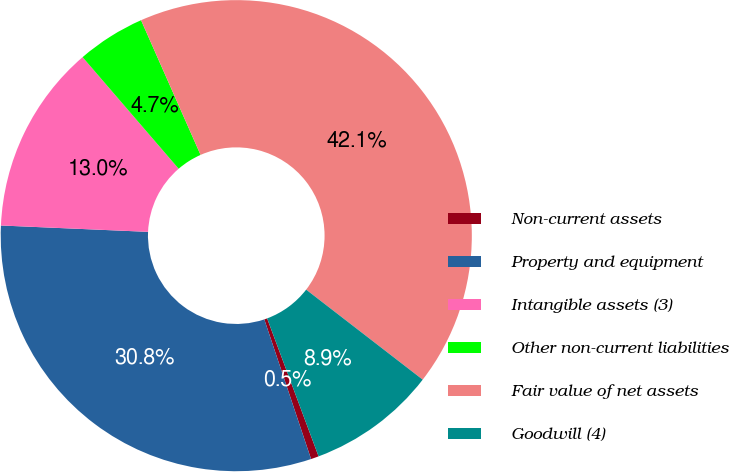Convert chart to OTSL. <chart><loc_0><loc_0><loc_500><loc_500><pie_chart><fcel>Non-current assets<fcel>Property and equipment<fcel>Intangible assets (3)<fcel>Other non-current liabilities<fcel>Fair value of net assets<fcel>Goodwill (4)<nl><fcel>0.54%<fcel>30.83%<fcel>13.0%<fcel>4.69%<fcel>42.09%<fcel>8.85%<nl></chart> 